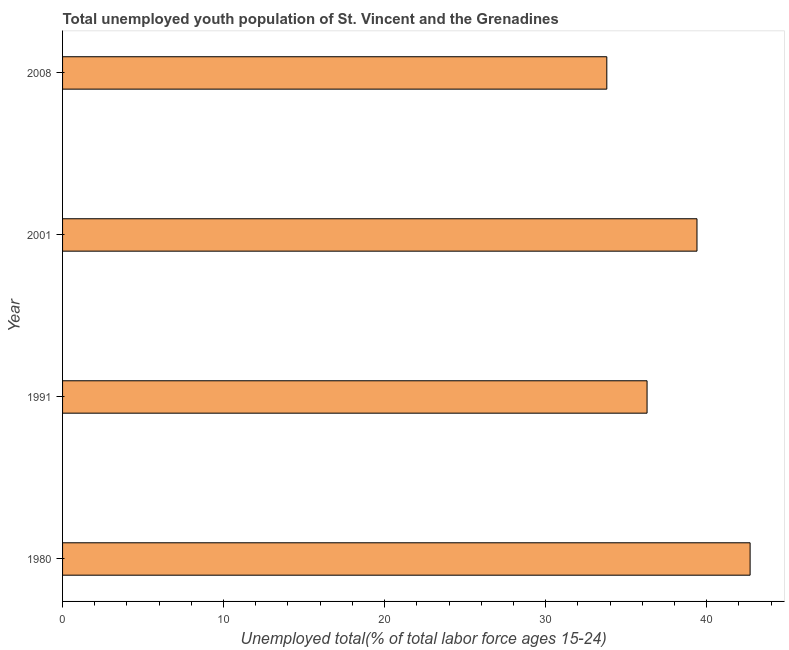Does the graph contain grids?
Your answer should be very brief. No. What is the title of the graph?
Make the answer very short. Total unemployed youth population of St. Vincent and the Grenadines. What is the label or title of the X-axis?
Keep it short and to the point. Unemployed total(% of total labor force ages 15-24). What is the unemployed youth in 1991?
Offer a very short reply. 36.3. Across all years, what is the maximum unemployed youth?
Your response must be concise. 42.7. Across all years, what is the minimum unemployed youth?
Your response must be concise. 33.8. In which year was the unemployed youth maximum?
Your response must be concise. 1980. What is the sum of the unemployed youth?
Make the answer very short. 152.2. What is the average unemployed youth per year?
Offer a very short reply. 38.05. What is the median unemployed youth?
Your response must be concise. 37.85. Do a majority of the years between 2008 and 1980 (inclusive) have unemployed youth greater than 2 %?
Ensure brevity in your answer.  Yes. What is the ratio of the unemployed youth in 2001 to that in 2008?
Your answer should be compact. 1.17. Is the unemployed youth in 1991 less than that in 2001?
Your response must be concise. Yes. What is the difference between the highest and the lowest unemployed youth?
Keep it short and to the point. 8.9. In how many years, is the unemployed youth greater than the average unemployed youth taken over all years?
Offer a very short reply. 2. How many bars are there?
Make the answer very short. 4. What is the difference between two consecutive major ticks on the X-axis?
Keep it short and to the point. 10. Are the values on the major ticks of X-axis written in scientific E-notation?
Offer a terse response. No. What is the Unemployed total(% of total labor force ages 15-24) in 1980?
Your response must be concise. 42.7. What is the Unemployed total(% of total labor force ages 15-24) of 1991?
Provide a short and direct response. 36.3. What is the Unemployed total(% of total labor force ages 15-24) in 2001?
Give a very brief answer. 39.4. What is the Unemployed total(% of total labor force ages 15-24) of 2008?
Ensure brevity in your answer.  33.8. What is the difference between the Unemployed total(% of total labor force ages 15-24) in 1980 and 1991?
Make the answer very short. 6.4. What is the difference between the Unemployed total(% of total labor force ages 15-24) in 1980 and 2001?
Give a very brief answer. 3.3. What is the difference between the Unemployed total(% of total labor force ages 15-24) in 1980 and 2008?
Provide a short and direct response. 8.9. What is the difference between the Unemployed total(% of total labor force ages 15-24) in 1991 and 2001?
Offer a terse response. -3.1. What is the difference between the Unemployed total(% of total labor force ages 15-24) in 1991 and 2008?
Ensure brevity in your answer.  2.5. What is the ratio of the Unemployed total(% of total labor force ages 15-24) in 1980 to that in 1991?
Offer a terse response. 1.18. What is the ratio of the Unemployed total(% of total labor force ages 15-24) in 1980 to that in 2001?
Ensure brevity in your answer.  1.08. What is the ratio of the Unemployed total(% of total labor force ages 15-24) in 1980 to that in 2008?
Ensure brevity in your answer.  1.26. What is the ratio of the Unemployed total(% of total labor force ages 15-24) in 1991 to that in 2001?
Your response must be concise. 0.92. What is the ratio of the Unemployed total(% of total labor force ages 15-24) in 1991 to that in 2008?
Give a very brief answer. 1.07. What is the ratio of the Unemployed total(% of total labor force ages 15-24) in 2001 to that in 2008?
Provide a succinct answer. 1.17. 